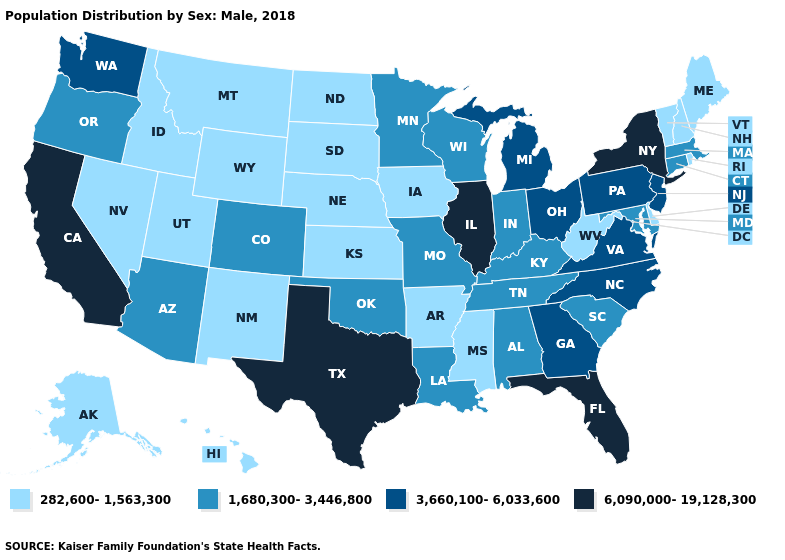What is the lowest value in the USA?
Answer briefly. 282,600-1,563,300. Does Virginia have the same value as Vermont?
Short answer required. No. Does Connecticut have a higher value than Indiana?
Keep it brief. No. What is the value of Alabama?
Give a very brief answer. 1,680,300-3,446,800. What is the lowest value in the Northeast?
Concise answer only. 282,600-1,563,300. What is the lowest value in the USA?
Keep it brief. 282,600-1,563,300. Which states have the lowest value in the USA?
Give a very brief answer. Alaska, Arkansas, Delaware, Hawaii, Idaho, Iowa, Kansas, Maine, Mississippi, Montana, Nebraska, Nevada, New Hampshire, New Mexico, North Dakota, Rhode Island, South Dakota, Utah, Vermont, West Virginia, Wyoming. Which states have the highest value in the USA?
Keep it brief. California, Florida, Illinois, New York, Texas. What is the lowest value in states that border North Carolina?
Write a very short answer. 1,680,300-3,446,800. Does Florida have the highest value in the South?
Write a very short answer. Yes. What is the lowest value in the USA?
Answer briefly. 282,600-1,563,300. What is the lowest value in the West?
Quick response, please. 282,600-1,563,300. Which states have the lowest value in the West?
Answer briefly. Alaska, Hawaii, Idaho, Montana, Nevada, New Mexico, Utah, Wyoming. What is the lowest value in the USA?
Short answer required. 282,600-1,563,300. 